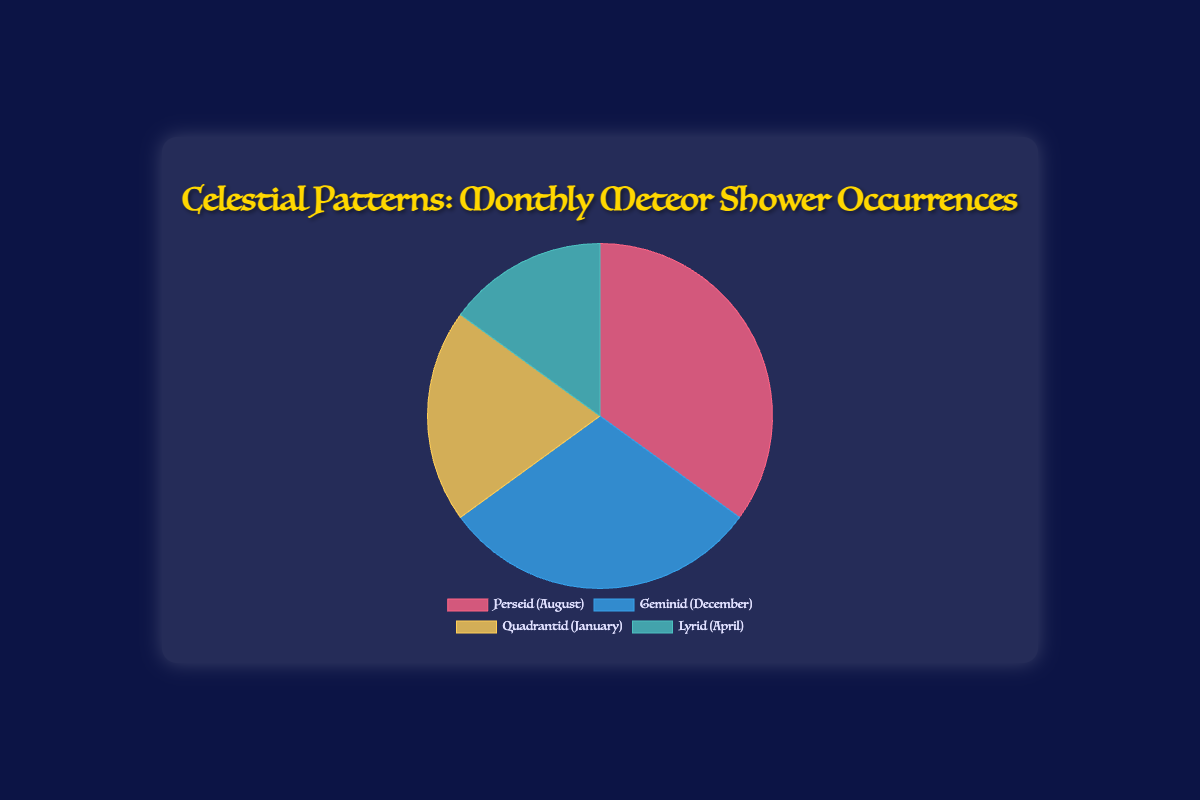What percentage of the monthly meteor shower occurrences is attributed to the Perseid Meteor Shower? The slice representing the Perseid Meteor Shower is 35% of the pie chart.
Answer: 35% Which meteor shower has the smallest share of monthly occurrences? The Lyrid Meteor Shower has the smallest slice at 15%.
Answer: Lyrid Meteor Shower How much larger is the share of the Perseid Meteor Shower compared to the Lyrid Meteor Shower? The Perseid Meteor Shower is 35% and the Lyrid Meteor Shower is 15%. The difference is 35% - 15% = 20%.
Answer: 20% Which meteor shower occurs more frequently, the Geminid or the Quadrantid? The Geminid Meteor Shower has a slice of 30%, while the Quadrantid Meteor Shower has 20%. Therefore, the Geminid occurs more frequently.
Answer: Geminid Meteor Shower What is the combined percentage of occurrences for the Geminid and Quadrantid Meteor Showers? The Geminid Meteor Shower occurs 30% of the time and the Quadrantid Meteor Shower occurs 20% of the time. Together, their occurrences sum to 30% + 20% = 50%.
Answer: 50% How does the percentage of the Lyrid Meteor Shower compare to the sum of the Quadrantid and Lyrid Meteor Showers? The Lyrid Meteor Shower is 15% and the Quadrantid is 20%. Their sum is 15% + 20% = 35%.
Answer: The sum is 20% more than the Lyrid alone Which meteor shower is represented by the greenish slice in the pie chart? The greenish slice corresponds to the Lyrid Meteor Shower.
Answer: Lyrid Meteor Shower If the Geminid Meteor Shower and Quadrantid Meteor Shower were combined into a new category, what percentage of the total occurrences would this new category represent? The combined percentage of the Geminid Meteor Shower (30%) and Quadrantid Meteor Shower (20%) would be 30% + 20% = 50%.
Answer: 50% What is the difference in percentage between the Perseid Meteor Shower and the combined Geminid and Quadrantid Meteor Showers? The combined percentage of the Geminid and Quadrantid Meteor Showers is 30% + 20% = 50%. The Perseid Meteor Shower is 35%. The difference is 50% - 35% = 15%.
Answer: 15% Order the meteor showers from most frequent to least frequent based on the chart. The percentages are 35% (Perseid), 30% (Geminid), 20% (Quadrantid), and 15% (Lyrid). Ordering from most frequent to least frequent gives: Perseid, Geminid, Quadrantid, Lyrid.
Answer: Perseid, Geminid, Quadrantid, Lyrid 